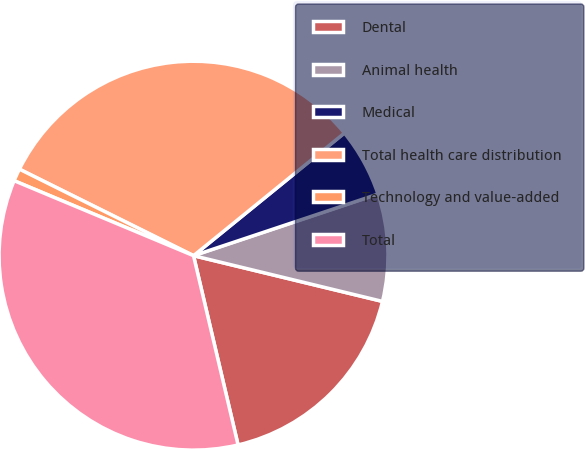Convert chart to OTSL. <chart><loc_0><loc_0><loc_500><loc_500><pie_chart><fcel>Dental<fcel>Animal health<fcel>Medical<fcel>Total health care distribution<fcel>Technology and value-added<fcel>Total<nl><fcel>17.54%<fcel>8.91%<fcel>5.73%<fcel>31.8%<fcel>1.04%<fcel>34.98%<nl></chart> 